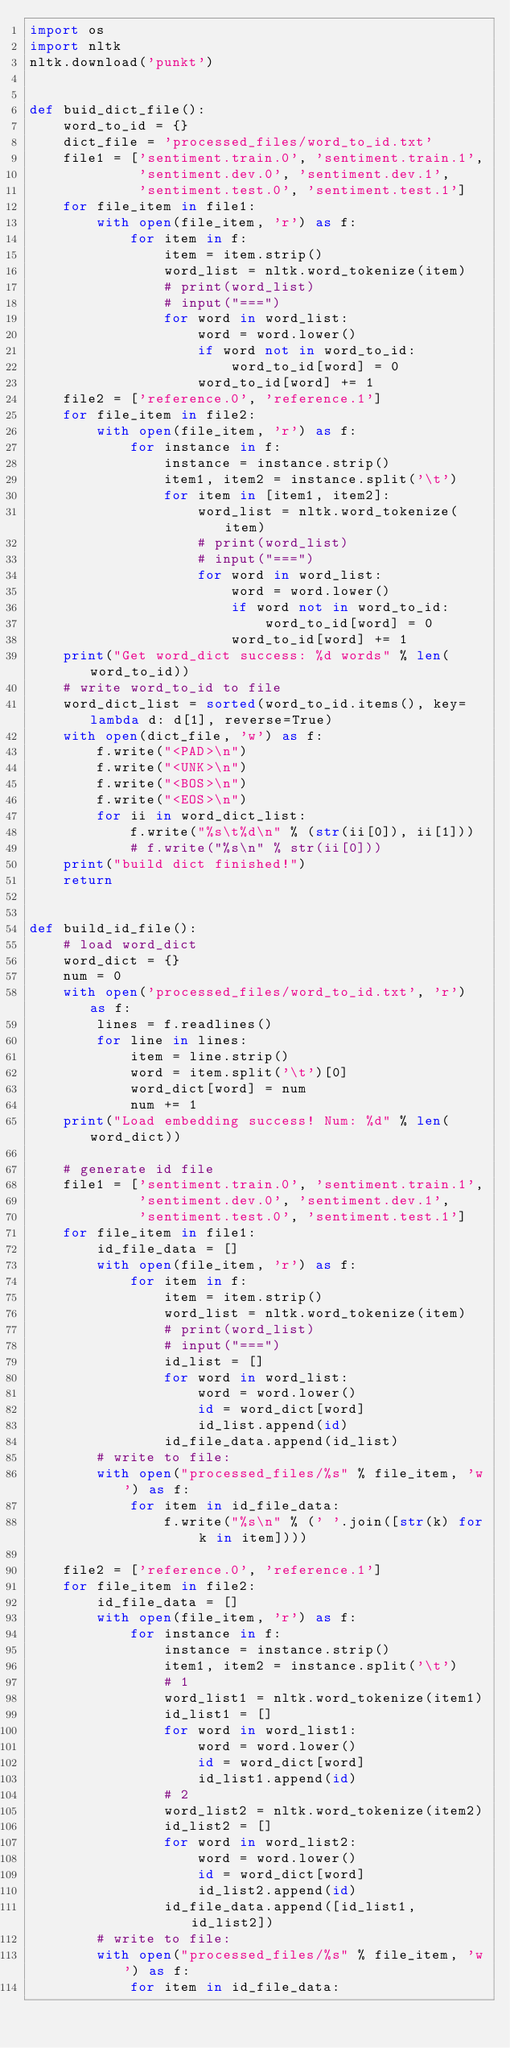<code> <loc_0><loc_0><loc_500><loc_500><_Python_>import os
import nltk
nltk.download('punkt')


def buid_dict_file():
    word_to_id = {}
    dict_file = 'processed_files/word_to_id.txt'
    file1 = ['sentiment.train.0', 'sentiment.train.1',
             'sentiment.dev.0', 'sentiment.dev.1',
             'sentiment.test.0', 'sentiment.test.1']
    for file_item in file1:
        with open(file_item, 'r') as f:
            for item in f:
                item = item.strip()
                word_list = nltk.word_tokenize(item)
                # print(word_list)
                # input("===")
                for word in word_list:
                    word = word.lower()
                    if word not in word_to_id:
                        word_to_id[word] = 0
                    word_to_id[word] += 1
    file2 = ['reference.0', 'reference.1']
    for file_item in file2:
        with open(file_item, 'r') as f:
            for instance in f:
                instance = instance.strip()
                item1, item2 = instance.split('\t')
                for item in [item1, item2]:
                    word_list = nltk.word_tokenize(item)
                    # print(word_list)
                    # input("===")
                    for word in word_list:
                        word = word.lower()
                        if word not in word_to_id:
                            word_to_id[word] = 0
                        word_to_id[word] += 1
    print("Get word_dict success: %d words" % len(word_to_id))
    # write word_to_id to file
    word_dict_list = sorted(word_to_id.items(), key=lambda d: d[1], reverse=True)
    with open(dict_file, 'w') as f:
        f.write("<PAD>\n")
        f.write("<UNK>\n")
        f.write("<BOS>\n")
        f.write("<EOS>\n")
        for ii in word_dict_list:
            f.write("%s\t%d\n" % (str(ii[0]), ii[1]))
            # f.write("%s\n" % str(ii[0]))
    print("build dict finished!")
    return


def build_id_file():
    # load word_dict
    word_dict = {}
    num = 0
    with open('processed_files/word_to_id.txt', 'r') as f:
        lines = f.readlines()
        for line in lines:
            item = line.strip()
            word = item.split('\t')[0]
            word_dict[word] = num
            num += 1
    print("Load embedding success! Num: %d" % len(word_dict))

    # generate id file
    file1 = ['sentiment.train.0', 'sentiment.train.1',
             'sentiment.dev.0', 'sentiment.dev.1',
             'sentiment.test.0', 'sentiment.test.1']
    for file_item in file1:
        id_file_data = []
        with open(file_item, 'r') as f:
            for item in f:
                item = item.strip()
                word_list = nltk.word_tokenize(item)
                # print(word_list)
                # input("===")
                id_list = []
                for word in word_list:
                    word = word.lower()
                    id = word_dict[word]
                    id_list.append(id)
                id_file_data.append(id_list)
        # write to file:
        with open("processed_files/%s" % file_item, 'w') as f:
            for item in id_file_data:
                f.write("%s\n" % (' '.join([str(k) for k in item])))

    file2 = ['reference.0', 'reference.1']
    for file_item in file2:
        id_file_data = []
        with open(file_item, 'r') as f:
            for instance in f:
                instance = instance.strip()
                item1, item2 = instance.split('\t')
                # 1
                word_list1 = nltk.word_tokenize(item1)
                id_list1 = []
                for word in word_list1:
                    word = word.lower()
                    id = word_dict[word]
                    id_list1.append(id)
                # 2
                word_list2 = nltk.word_tokenize(item2)
                id_list2 = []
                for word in word_list2:
                    word = word.lower()
                    id = word_dict[word]
                    id_list2.append(id)
                id_file_data.append([id_list1, id_list2])
        # write to file:
        with open("processed_files/%s" % file_item, 'w') as f:
            for item in id_file_data:</code> 